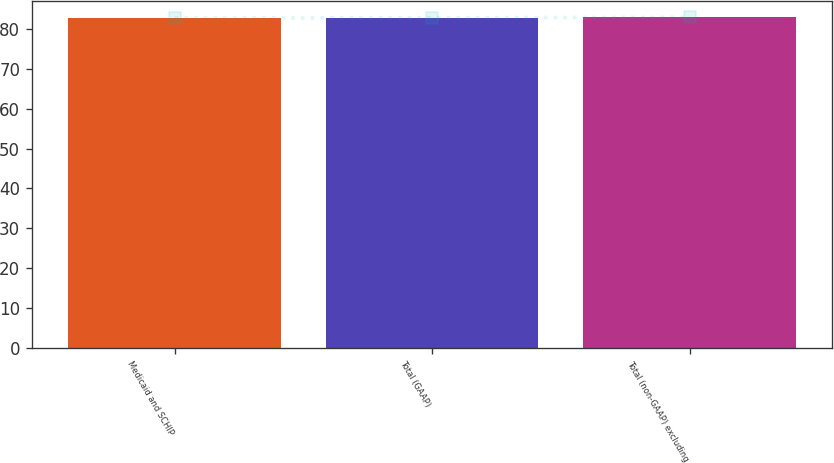Convert chart. <chart><loc_0><loc_0><loc_500><loc_500><bar_chart><fcel>Medicaid and SCHIP<fcel>Total (GAAP)<fcel>Total (non-GAAP) excluding<nl><fcel>82.8<fcel>82.9<fcel>83<nl></chart> 